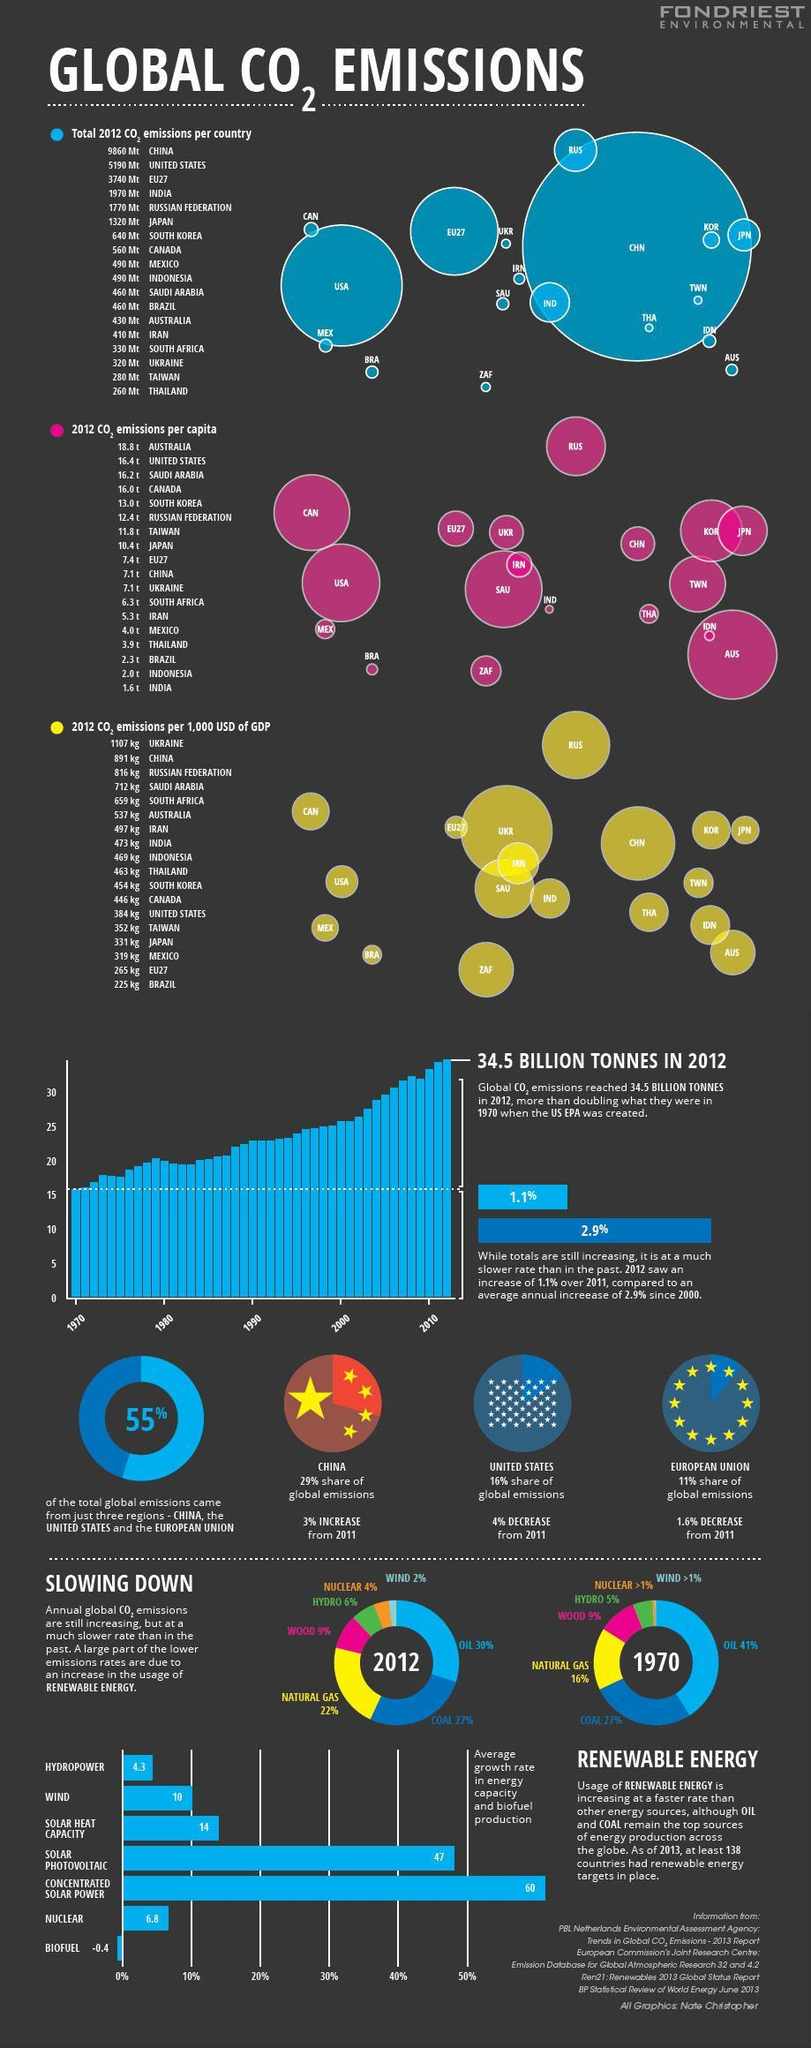Which country has the highest Carbon dioxide emissions, China, USA, or EU?
Answer the question with a short phrase. China By what percentage has the consumption of oil decreased in 2012 since 1970? 11% What is the Carbon emissions per capita in China and Ukraine? 7.1t What is carbon emissions produced by ZAF per capita? 6.3t Which renewable energy has a negative growth rate, Hydropower, Wind, or Biofuel ? Biofuel Which countries emitted carbon dioxide equal to 490 Mt in 2012? Mexico, Indonesia How many countries have emissions less than 500 Mt? 10 What is the carbon dioxide emissions of Saudi Arabia and Brazil? 460 Mt What is the percentage increase in natural gas since 1970? 6% What is the carbon emissions per 1,000 USD of GDP contributed by JPN? 331 kg 